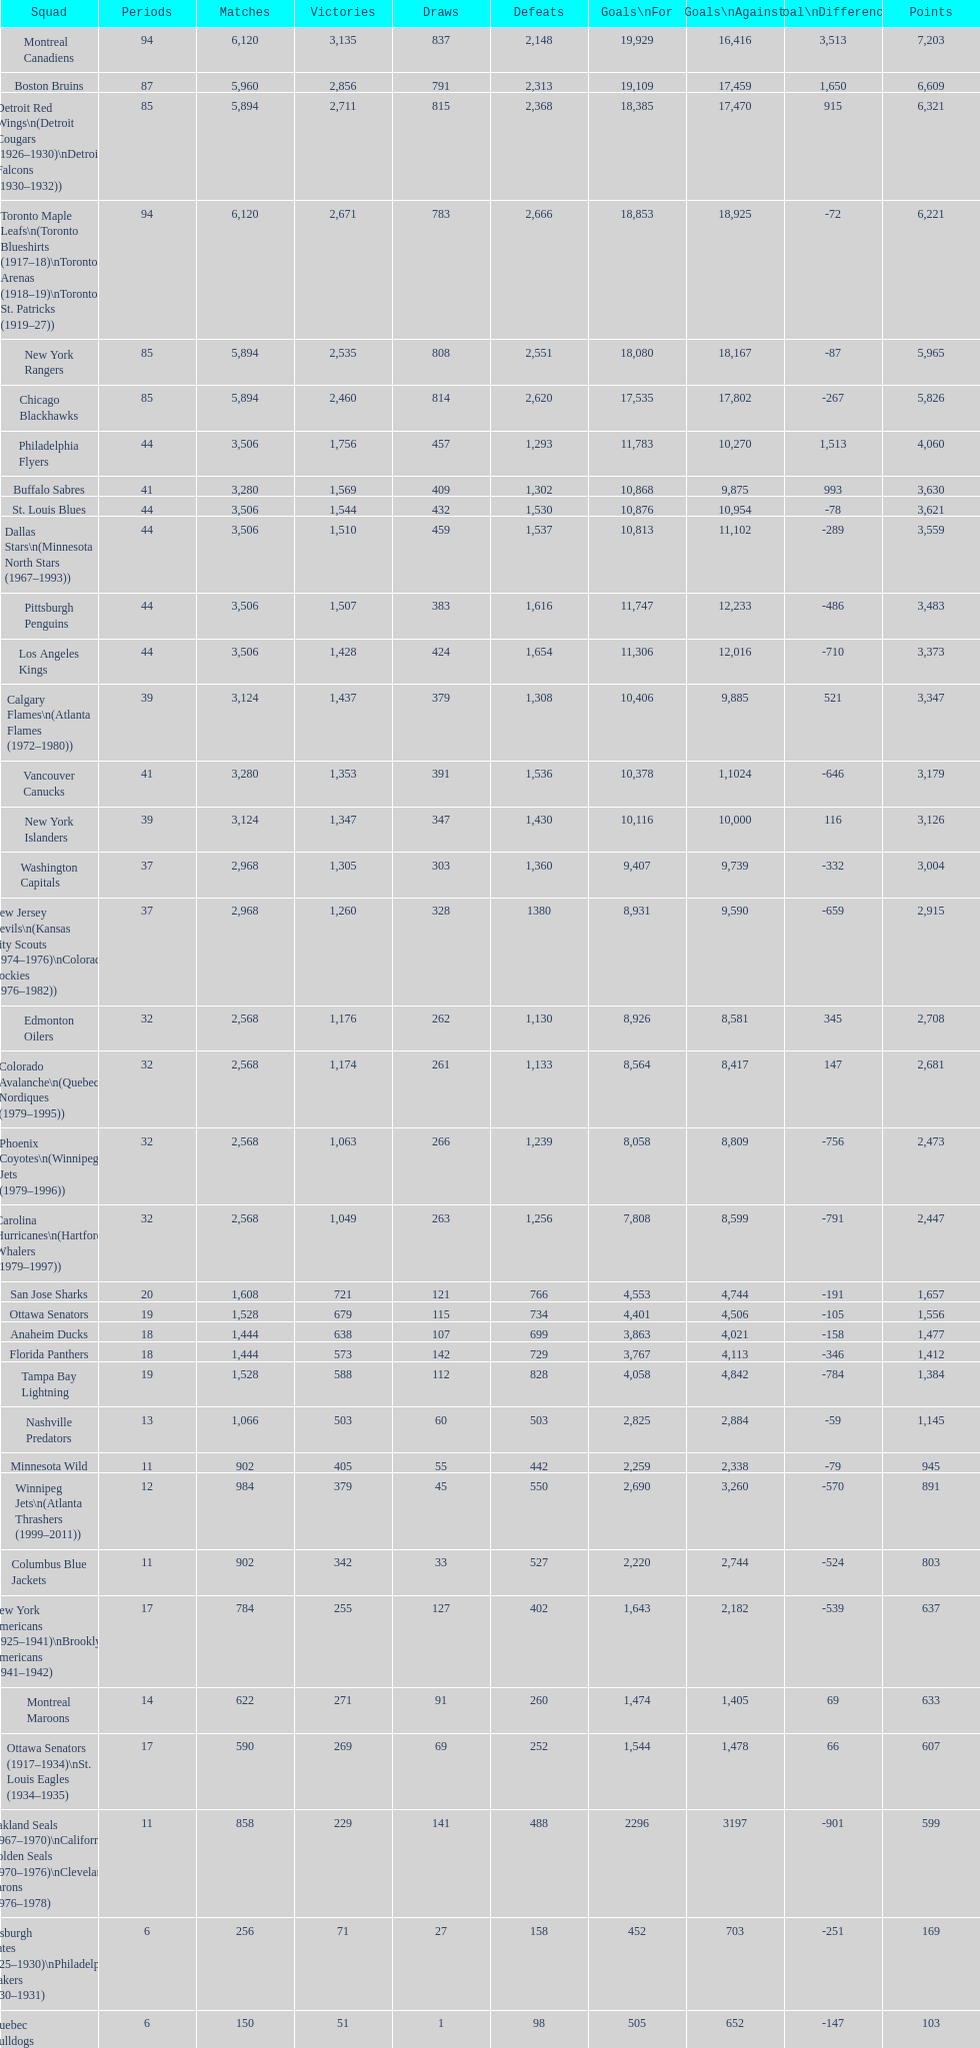What is the number of games that the vancouver canucks have won up to this point? 1,353. 